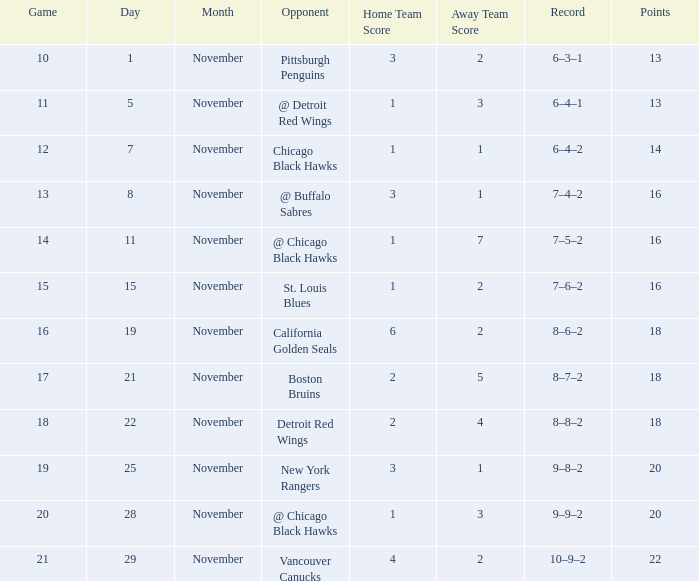What record has a november greater than 11, and st. louis blues as the opponent? 7–6–2. 